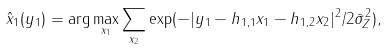<formula> <loc_0><loc_0><loc_500><loc_500>\hat { x } _ { 1 } ( y _ { 1 } ) = \arg \max _ { x _ { 1 } } \sum _ { x _ { 2 } } \exp ( - | y _ { 1 } - h _ { 1 , 1 } x _ { 1 } - h _ { 1 , 2 } x _ { 2 } | ^ { 2 } / 2 \bar { \sigma } _ { Z } ^ { 2 } ) ,</formula> 